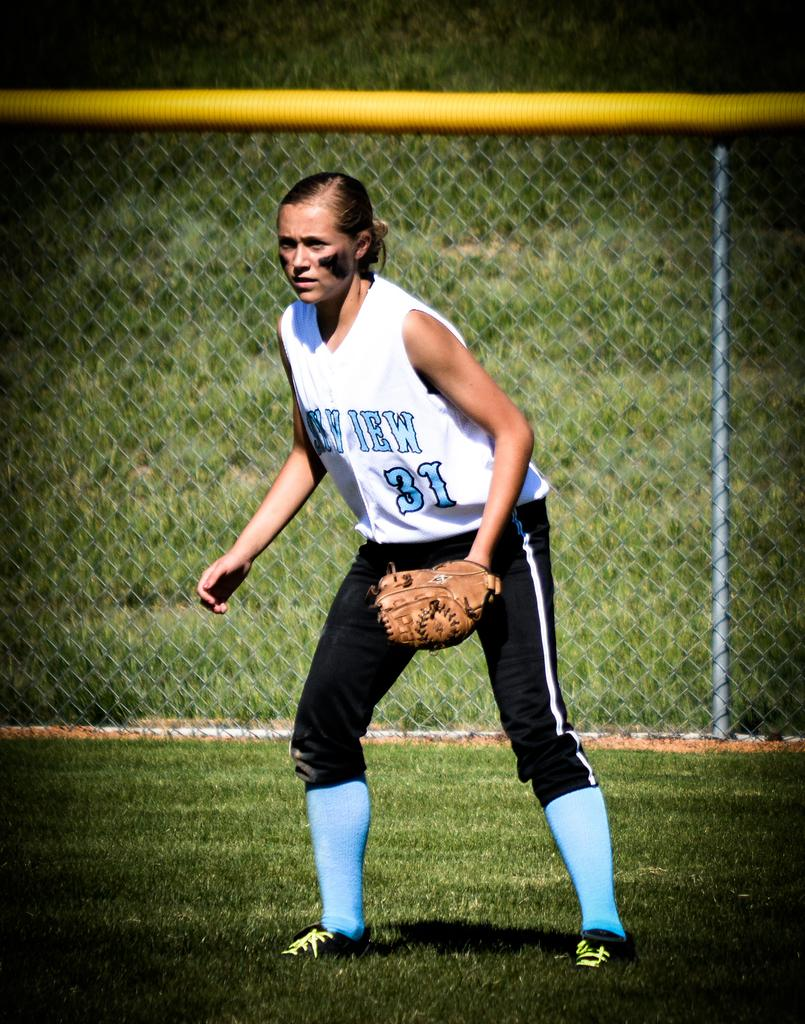<image>
Share a concise interpretation of the image provided. Player number 31 has black makup on her cheeks. 